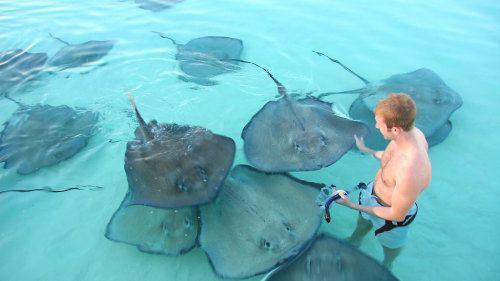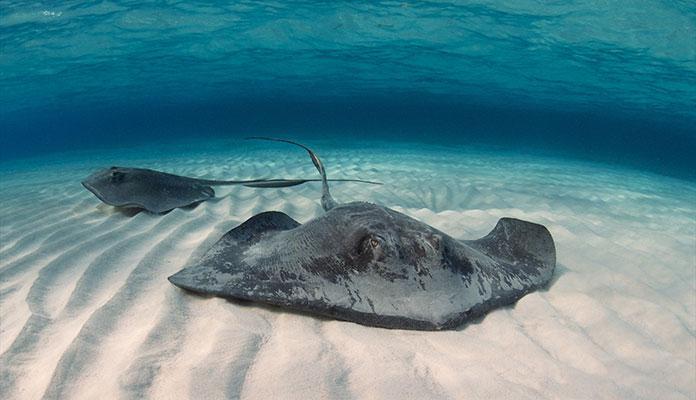The first image is the image on the left, the second image is the image on the right. Analyze the images presented: Is the assertion "The right image shows no human beings." valid? Answer yes or no. Yes. The first image is the image on the left, the second image is the image on the right. For the images shown, is this caption "The image on the left is taken from out of the water, and the image on the right is taken from in the water." true? Answer yes or no. Yes. 